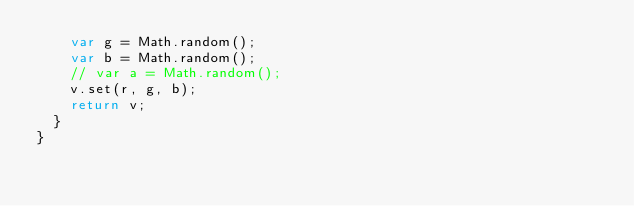Convert code to text. <code><loc_0><loc_0><loc_500><loc_500><_Haxe_>		var g = Math.random();
		var b = Math.random();
		// var a = Math.random();
		v.set(r, g, b);
		return v;
	}
}
</code> 